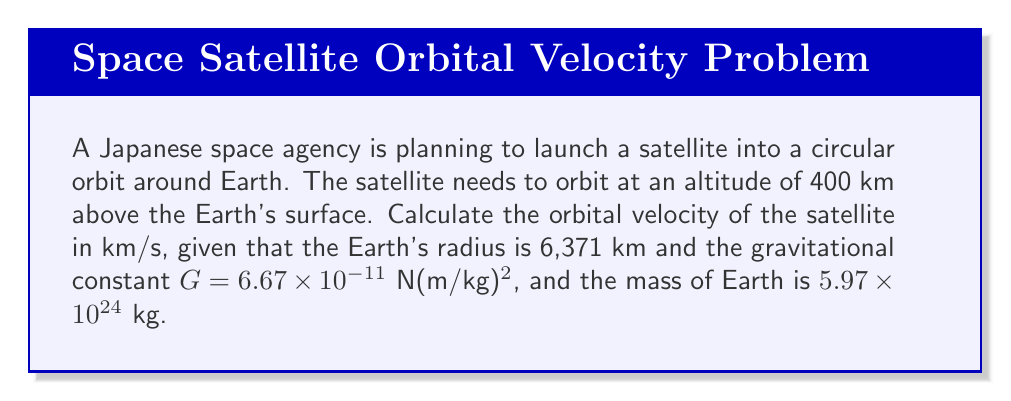Give your solution to this math problem. To solve this problem, we'll use the formula for orbital velocity in a circular orbit:

$$ v = \sqrt{\frac{GM}{r}} $$

Where:
- $v$ is the orbital velocity
- $G$ is the gravitational constant
- $M$ is the mass of the Earth
- $r$ is the distance from the center of the Earth to the satellite

Let's solve this step by step:

1. Calculate the distance $r$:
   $r = \text{Earth's radius} + \text{Satellite's altitude}$
   $r = 6,371 \text{ km} + 400 \text{ km} = 6,771 \text{ km}$

2. Convert $r$ to meters:
   $r = 6,771,000 \text{ m}$

3. Substitute the values into the orbital velocity formula:
   $$ v = \sqrt{\frac{(6.67 \times 10^{-11})(5.97 \times 10^{24})}{6,771,000}} $$

4. Calculate:
   $$ v = \sqrt{3.986 \times 10^{14} / 6,771,000} $$
   $$ v = \sqrt{58,867.96} $$
   $$ v = 7,669.73 \text{ m/s} $$

5. Convert the result to km/s:
   $$ v = 7.67 \text{ km/s} $$
Answer: The orbital velocity of the satellite is approximately 7.67 km/s. 